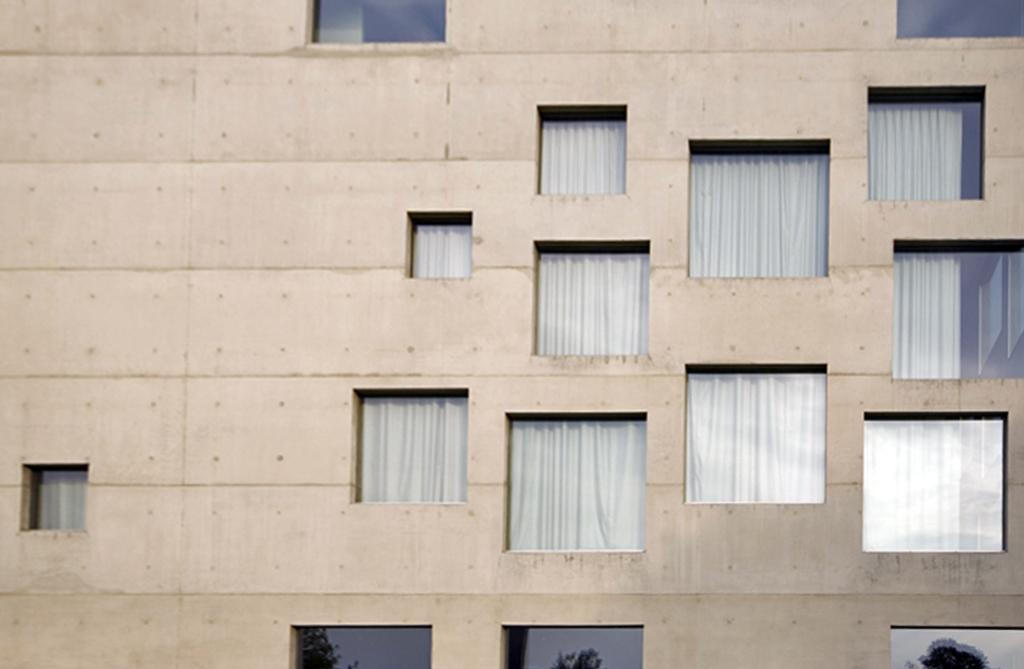What type of openings can be seen in the image? There are windows in the image. What type of window treatment is present in the image? There are curtains in the image. How does the visitor feel about the curtains in the image? There is no visitor present in the image, so it is not possible to determine their feelings about the curtains. 